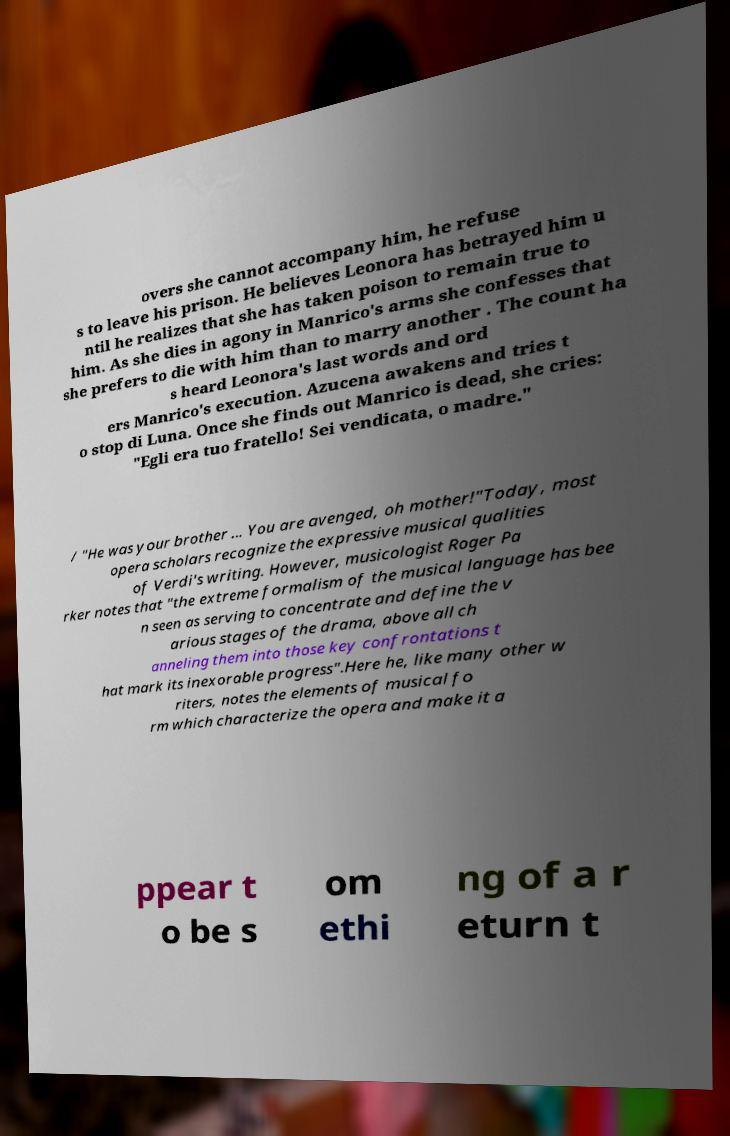Please read and relay the text visible in this image. What does it say? overs she cannot accompany him, he refuse s to leave his prison. He believes Leonora has betrayed him u ntil he realizes that she has taken poison to remain true to him. As she dies in agony in Manrico's arms she confesses that she prefers to die with him than to marry another . The count ha s heard Leonora's last words and ord ers Manrico's execution. Azucena awakens and tries t o stop di Luna. Once she finds out Manrico is dead, she cries: "Egli era tuo fratello! Sei vendicata, o madre." / "He was your brother ... You are avenged, oh mother!"Today, most opera scholars recognize the expressive musical qualities of Verdi's writing. However, musicologist Roger Pa rker notes that "the extreme formalism of the musical language has bee n seen as serving to concentrate and define the v arious stages of the drama, above all ch anneling them into those key confrontations t hat mark its inexorable progress".Here he, like many other w riters, notes the elements of musical fo rm which characterize the opera and make it a ppear t o be s om ethi ng of a r eturn t 